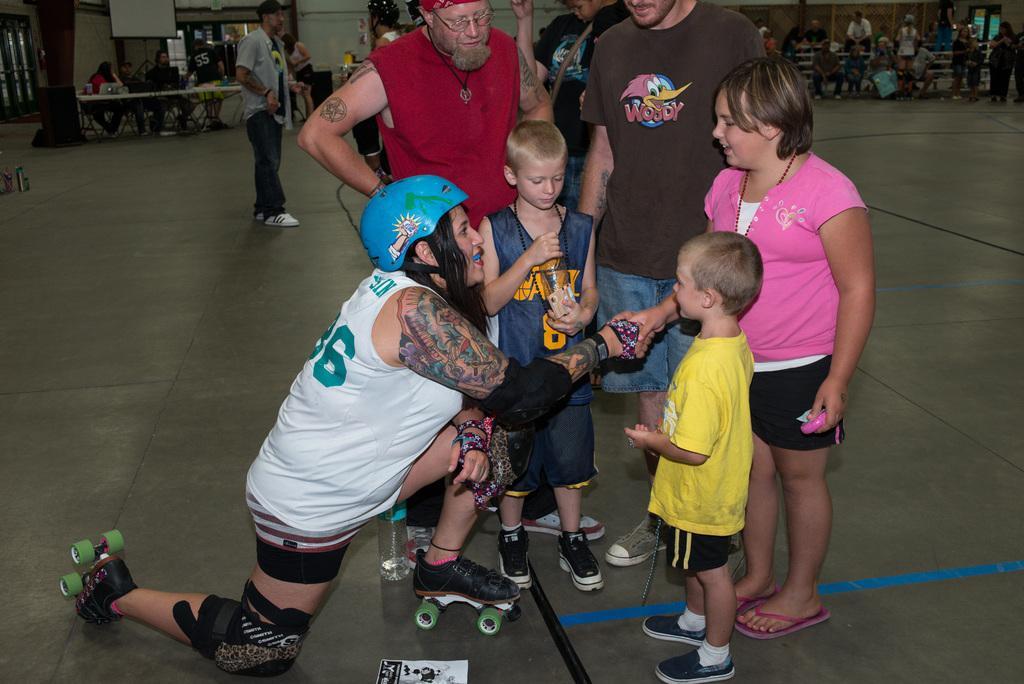Can you describe this image briefly? There is one person sitting on the floor is sitting on the floor is wearing white color t shirt and blue color helmet, and there are some persons standing on the right side to this person as we can see in the middle of this image. There are some persons sitting on the tables as we can see at the top right corner and top left corner of this image as well. There is one bottle and a book is kept on the floor at the bottom of this image. 